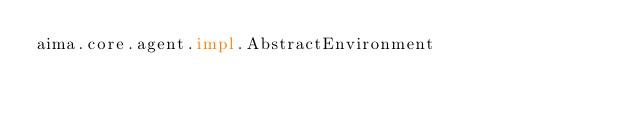<code> <loc_0><loc_0><loc_500><loc_500><_Rust_>aima.core.agent.impl.AbstractEnvironment
</code> 